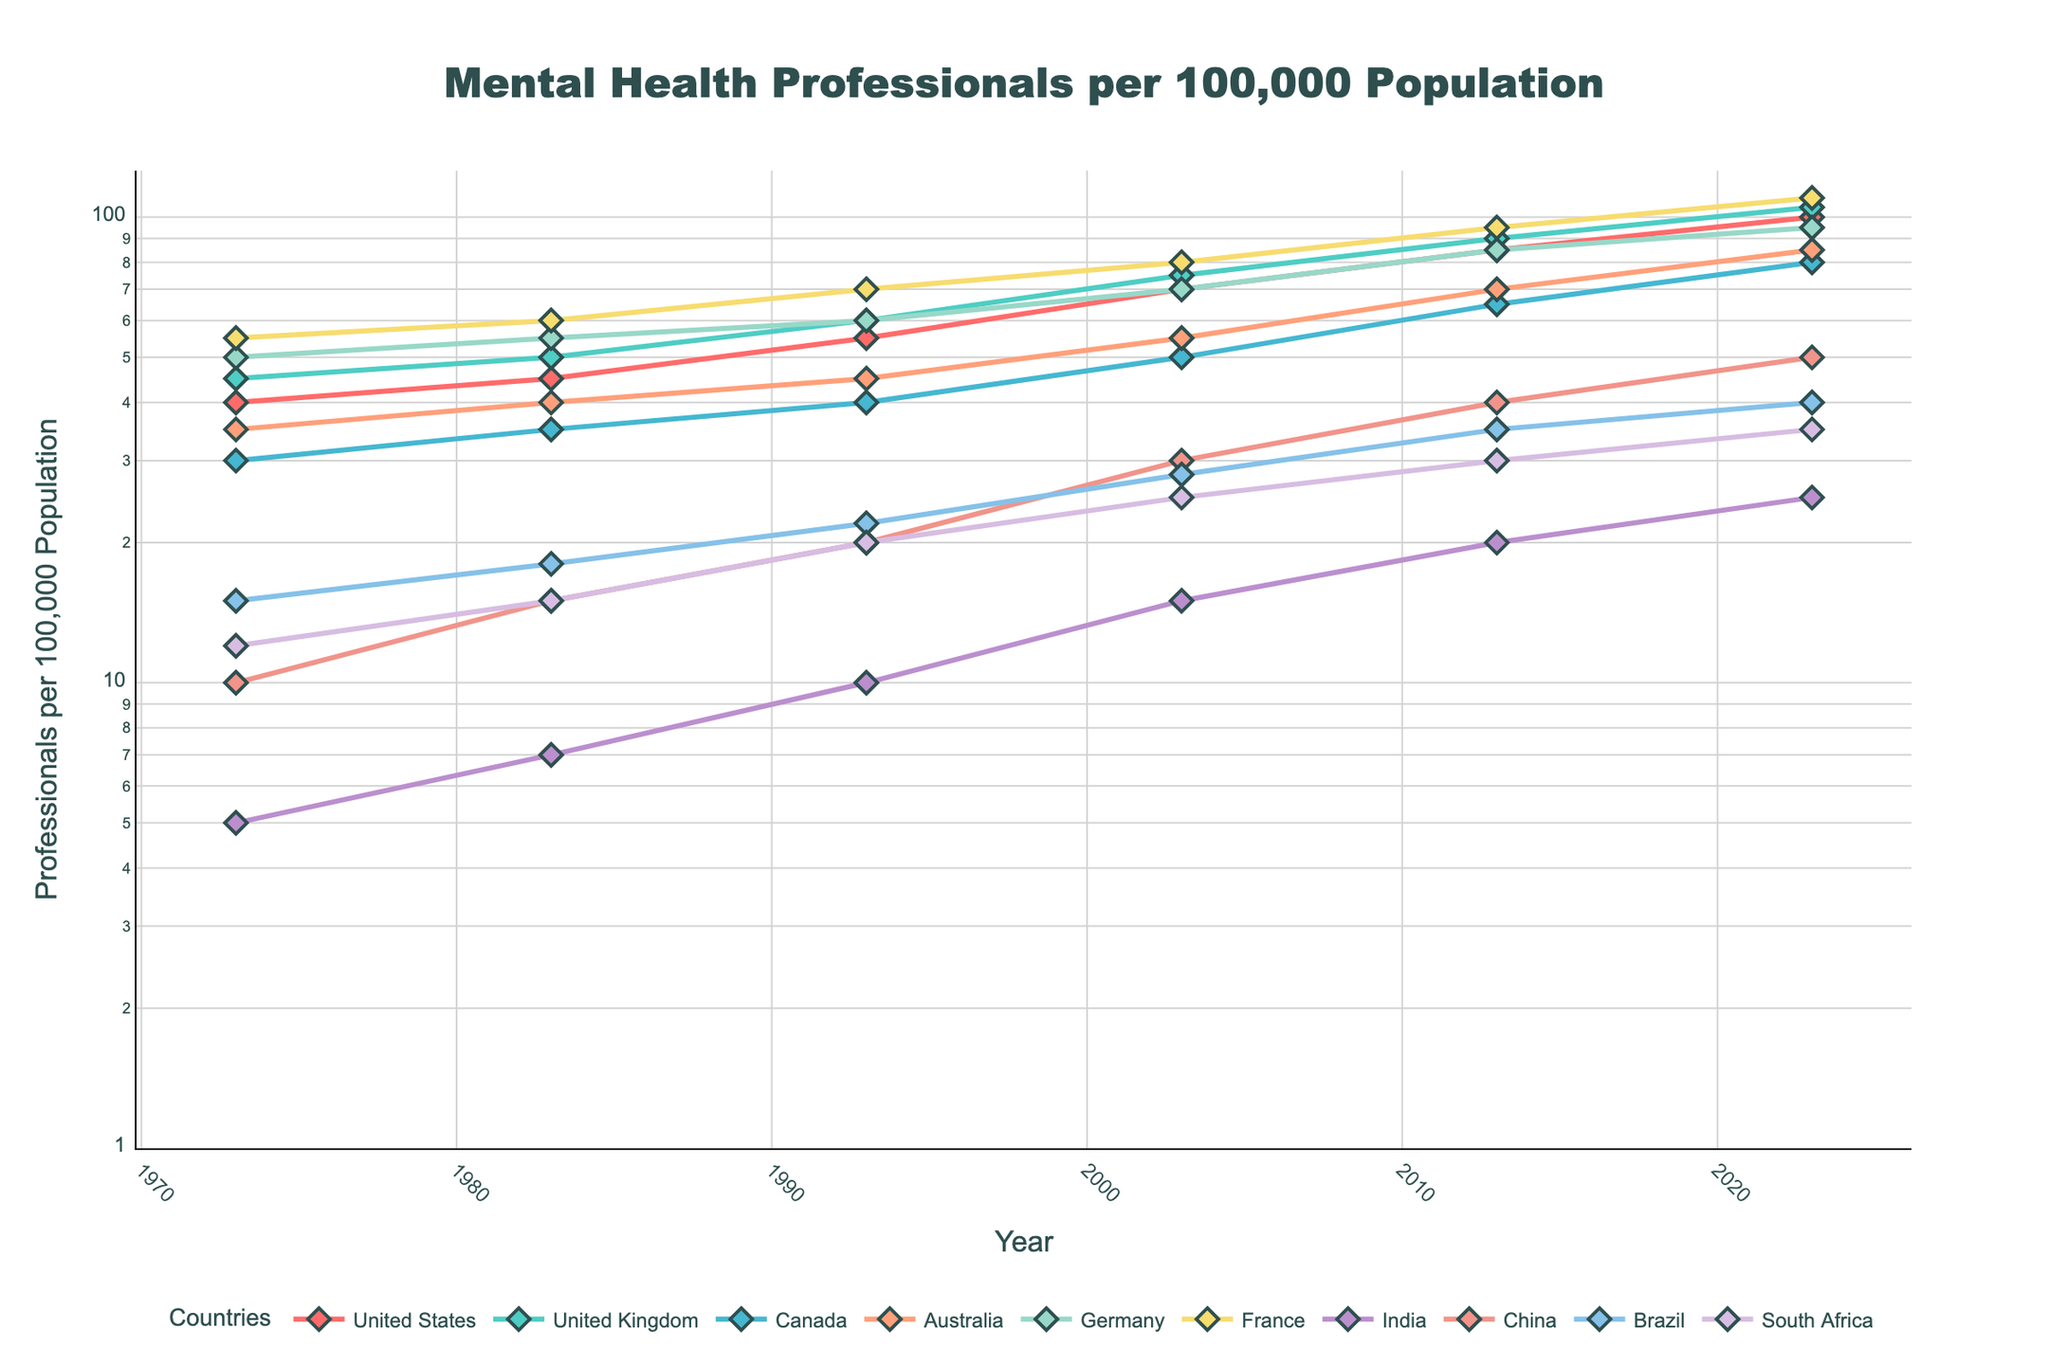What's the title of the figure? The title is typically displayed prominently at the top of the figure. From the code, we know the title is set as "Mental Health Professionals per 100,000 Population".
Answer: Mental Health Professionals per 100,000 Population What's the y-axis representing and how is it scaled? The y-axis represents the number of mental health professionals per 100,000 population. The axis is scaled logarithmically, meaning that each tick mark on the axis represents a power of 10 rather than a linear increment.
Answer: Number of mental health professionals per 100,000 population, Log scale Which country had the highest rate in 2023? The highest rate can be found by looking at the end points of the lines on the figure. The United Kingdom appears to have the highest end point in 2023, matching the data values from the figure.
Answer: United Kingdom What was the trend for China over the 50 years? To determine the trend, observe the line corresponding to China. It starts low and consistently rises throughout the 50-year period, reflecting an increase from 10 to 50 professionals per 100,000 population.
Answer: Increasing steadily What is the difference in the rate of mental health professionals between the United States and India in 2023? To find the difference in the rates, locate the 2023 data points for both the United States and India: 100 for the United States and 25 for India. Subtract India's value from the United States' value (100 - 25).
Answer: 75 How many countries had a rate of less than 20 professionals per 100,000 population in 1983? Check the values for each country in 1983: United States (45), United Kingdom (50), Canada (35), Australia (40), Germany (55), France (60), India (7), China (15), Brazil (18), and South Africa (15). Countries with less than 20 are India, China, Brazil, and South Africa, totaling to 4.
Answer: 4 Which country experienced the most significant increase in the rate of mental health professionals from 1973 to 2023? To determine the most significant increase, subtract the 1973 values from the 2023 values for each country and compare. The maximum difference is for the United Kingdom (105 - 45 = 60).
Answer: United Kingdom Compare the rates of mental health professionals between Canada and Australia in 2013. Which country had a higher rate? Find the 2013 data points for both Canada (65) and Australia (70). Since 70 is greater than 65, Australia had a higher rate.
Answer: Australia What is the average rate of mental health professionals for Germany in the given years? Sum the rates for Germany: 50 + 55 + 60 + 70 + 85 + 95 = 415. There are 6 data points, so divide the total by 6 (415 / 6 ≈ 69.17).
Answer: 69.17 How does the trend for South Africa compare to that of Brazil over 50 years? Both countries show an increasing trend. Starting from lower values in 1973, South Africa (12 to 35) and Brazil (15 to 40). Comparing their slopes, South Africa's trend is slightly less steep than Brazil's.
Answer: Both increasing, Brazil steeper 